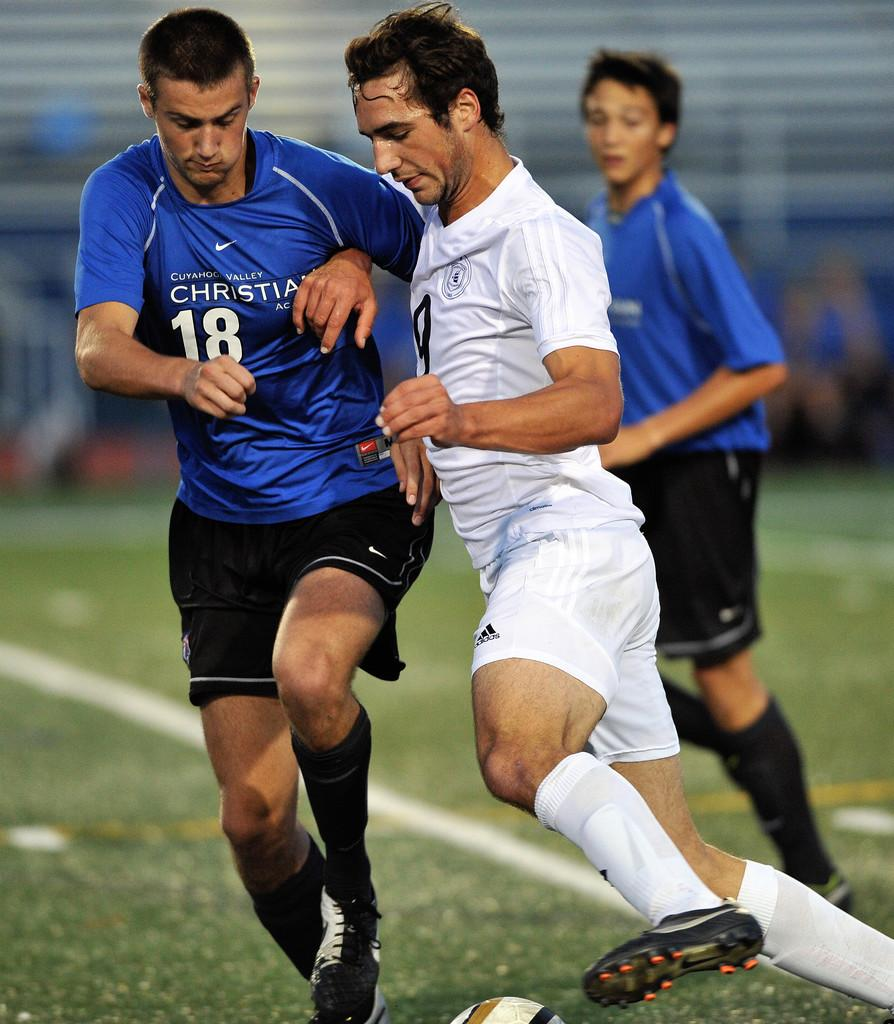<image>
Render a clear and concise summary of the photo. Soccer players with one wearing a blue shirt which says the number 18. 